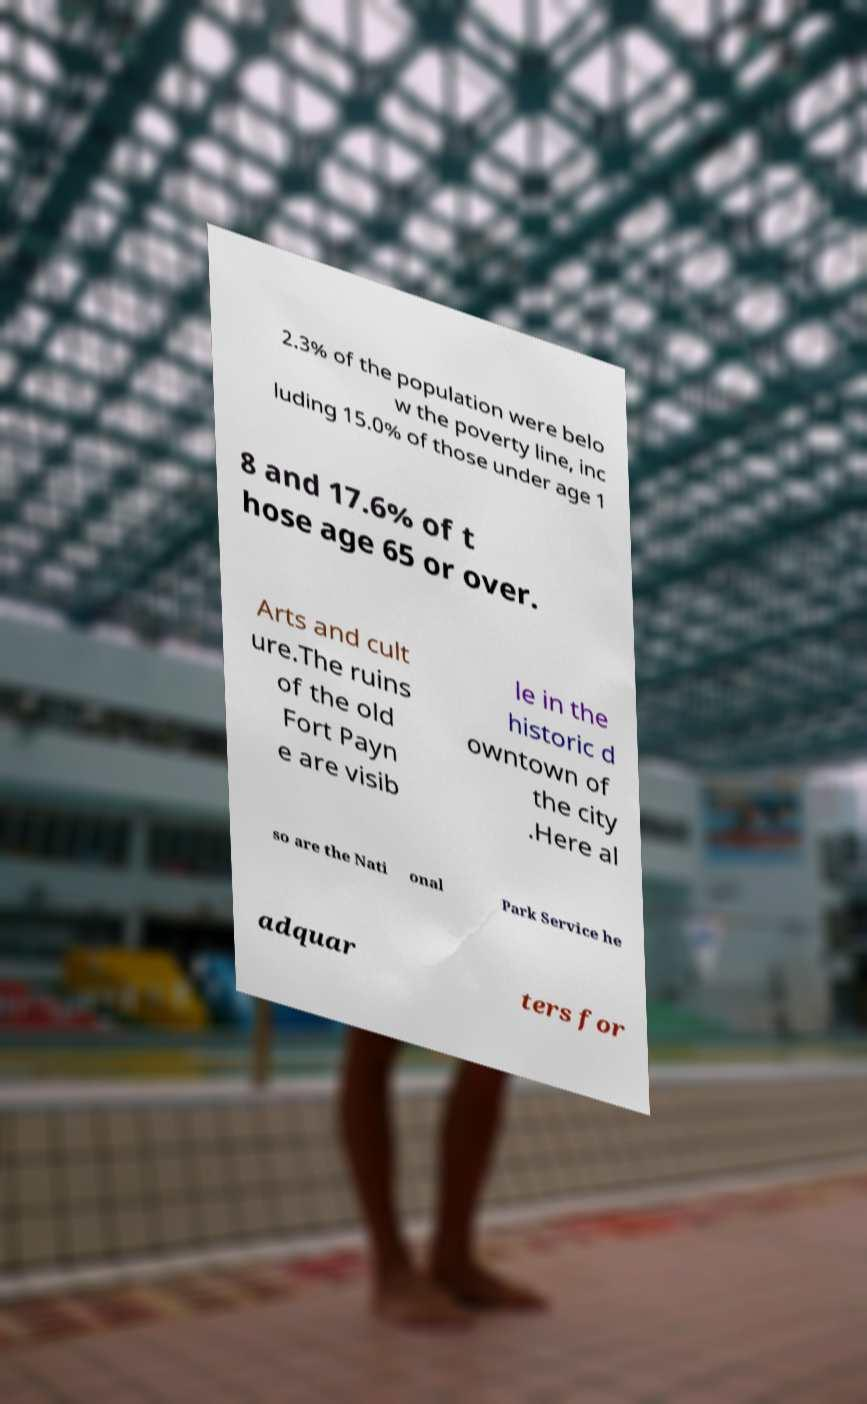Could you extract and type out the text from this image? 2.3% of the population were belo w the poverty line, inc luding 15.0% of those under age 1 8 and 17.6% of t hose age 65 or over. Arts and cult ure.The ruins of the old Fort Payn e are visib le in the historic d owntown of the city .Here al so are the Nati onal Park Service he adquar ters for 